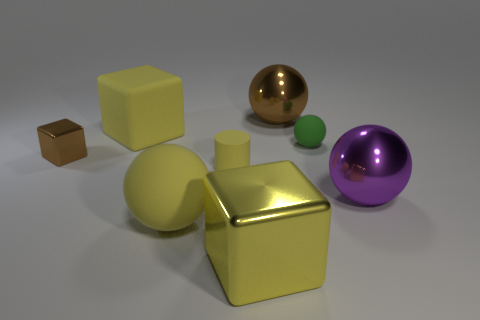Subtract all red spheres. Subtract all gray cubes. How many spheres are left? 4 Add 1 brown shiny blocks. How many objects exist? 9 Subtract all cubes. How many objects are left? 5 Add 5 cyan matte cylinders. How many cyan matte cylinders exist? 5 Subtract 0 gray spheres. How many objects are left? 8 Subtract all large yellow rubber things. Subtract all tiny rubber cylinders. How many objects are left? 5 Add 5 big yellow rubber things. How many big yellow rubber things are left? 7 